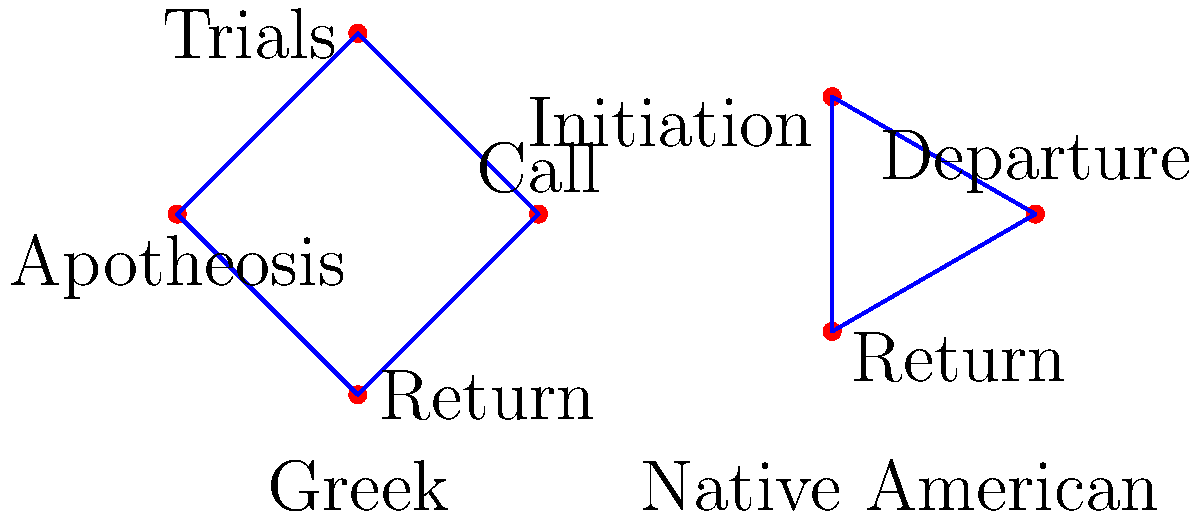In the cyclic graph representation of hero's journey structures, what is the primary difference between the Greek and Native American models, and how might this reflect differences in cultural storytelling traditions? To answer this question, let's analyze the cyclic graphs step by step:

1. Greek model:
   - Contains 4 stages: Call, Trials, Apotheosis, and Return
   - Forms a complete cycle with four distinct phases

2. Native American model:
   - Contains 3 stages: Departure, Initiation, and Return
   - Forms a complete cycle with three distinct phases

3. Key differences:
   a. Number of stages: Greek (4) vs. Native American (3)
   b. Specificity: Greek model is more detailed, especially in the middle stages
   c. Terminology: While both share "Return," other stages have different names

4. Cultural implications:
   a. Greek model's additional stage (Apotheosis) suggests a focus on personal transformation and divine elevation
   b. Native American model's simpler structure might indicate a more streamlined narrative approach
   c. The "Trials" in the Greek model vs. "Initiation" in the Native American model could reflect different emphases on the hero's challenges

5. Storytelling traditions:
   a. Greek: More elaborate, possibly reflecting longer epic traditions
   b. Native American: More concise, possibly indicating oral storytelling practices

6. Similarities:
   Both models are cyclical, suggesting a universal theme of the hero's return to their starting point, but transformed

The primary difference is the number of stages and their specific focus, reflecting varied cultural approaches to the hero's journey narrative structure.
Answer: The Greek model has four stages vs. three in the Native American model, reflecting more elaborate storytelling in Greek tradition and a more streamlined approach in Native American narratives. 